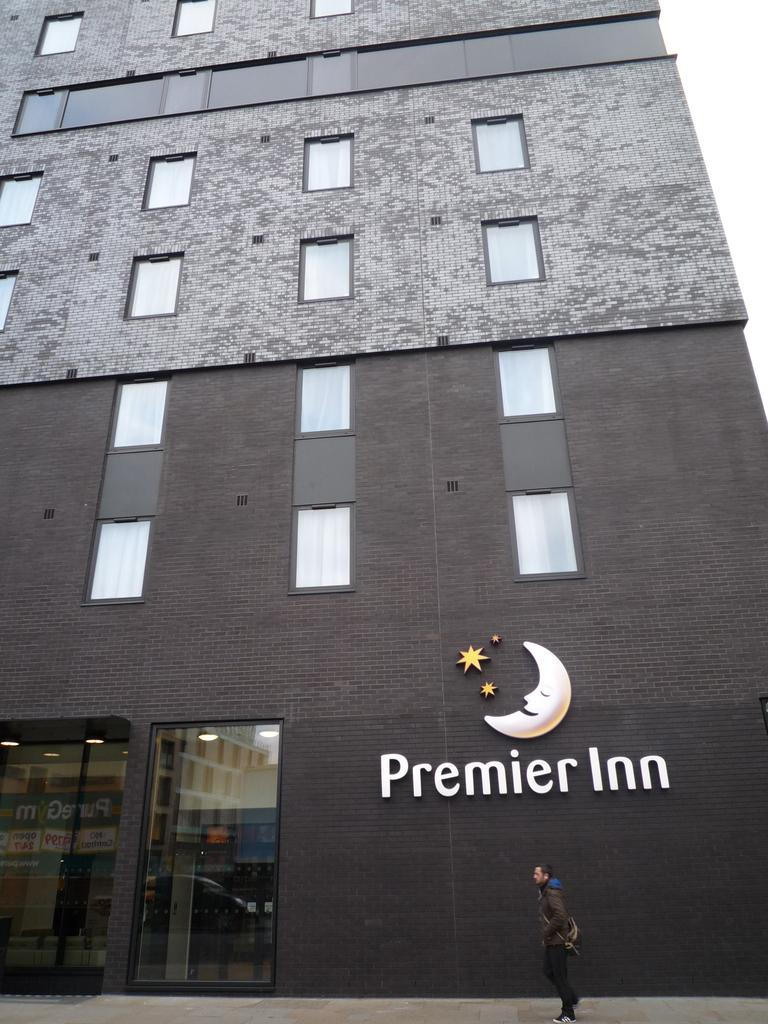<image>
Summarize the visual content of the image. A man walking in front of a building that says Premier Inn 